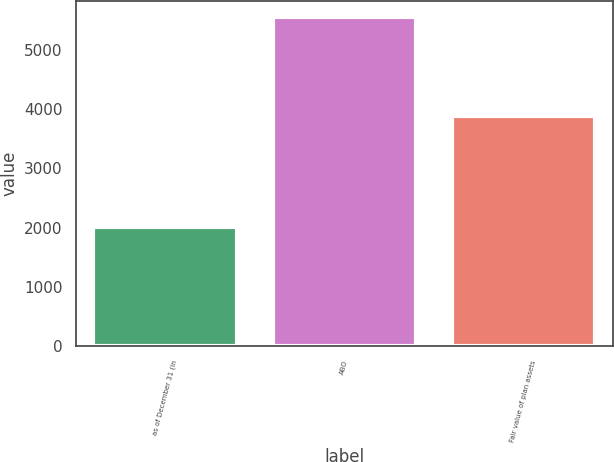Convert chart. <chart><loc_0><loc_0><loc_500><loc_500><bar_chart><fcel>as of December 31 (in<fcel>ABO<fcel>Fair value of plan assets<nl><fcel>2014<fcel>5550<fcel>3878<nl></chart> 